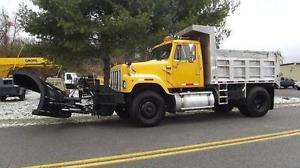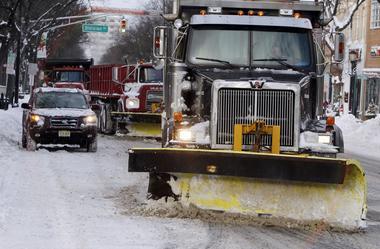The first image is the image on the left, the second image is the image on the right. Considering the images on both sides, is "At least one image shows a vehicle with tank-like tracks instead of wheels." valid? Answer yes or no. No. 